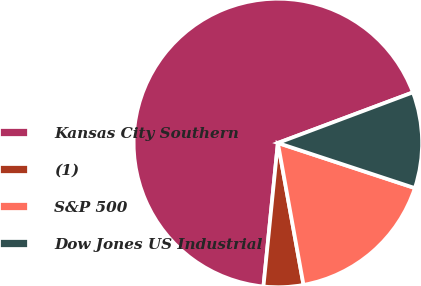Convert chart to OTSL. <chart><loc_0><loc_0><loc_500><loc_500><pie_chart><fcel>Kansas City Southern<fcel>(1)<fcel>S&P 500<fcel>Dow Jones US Industrial<nl><fcel>67.7%<fcel>4.44%<fcel>17.09%<fcel>10.77%<nl></chart> 